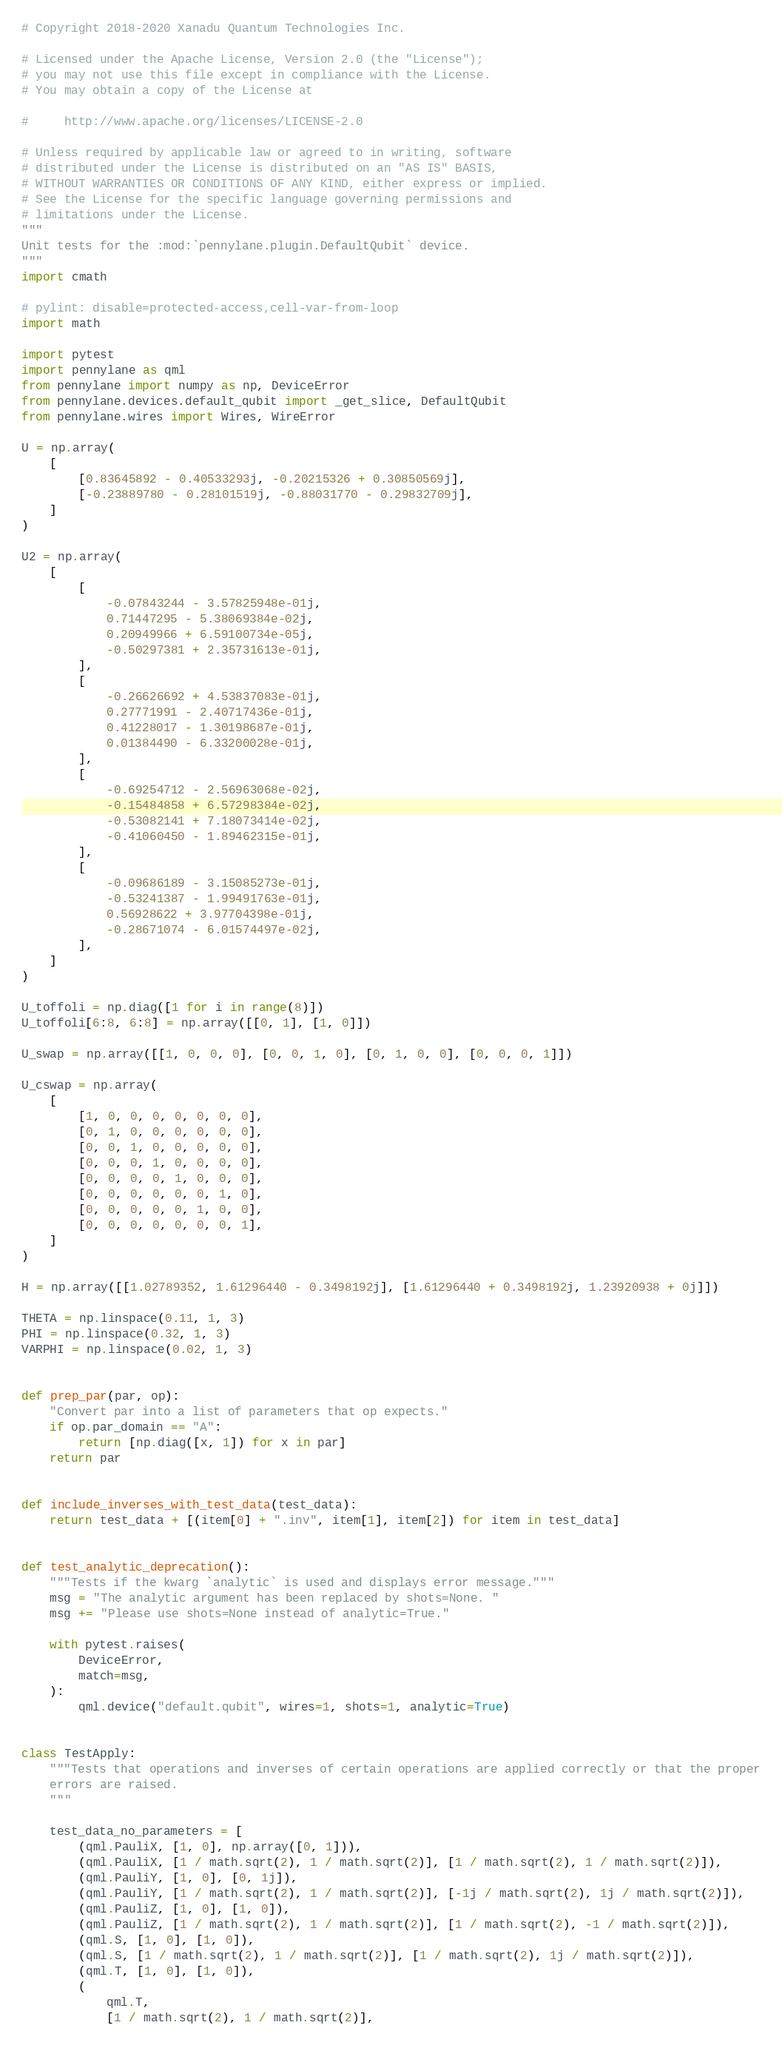<code> <loc_0><loc_0><loc_500><loc_500><_Python_># Copyright 2018-2020 Xanadu Quantum Technologies Inc.

# Licensed under the Apache License, Version 2.0 (the "License");
# you may not use this file except in compliance with the License.
# You may obtain a copy of the License at

#     http://www.apache.org/licenses/LICENSE-2.0

# Unless required by applicable law or agreed to in writing, software
# distributed under the License is distributed on an "AS IS" BASIS,
# WITHOUT WARRANTIES OR CONDITIONS OF ANY KIND, either express or implied.
# See the License for the specific language governing permissions and
# limitations under the License.
"""
Unit tests for the :mod:`pennylane.plugin.DefaultQubit` device.
"""
import cmath

# pylint: disable=protected-access,cell-var-from-loop
import math

import pytest
import pennylane as qml
from pennylane import numpy as np, DeviceError
from pennylane.devices.default_qubit import _get_slice, DefaultQubit
from pennylane.wires import Wires, WireError

U = np.array(
    [
        [0.83645892 - 0.40533293j, -0.20215326 + 0.30850569j],
        [-0.23889780 - 0.28101519j, -0.88031770 - 0.29832709j],
    ]
)

U2 = np.array(
    [
        [
            -0.07843244 - 3.57825948e-01j,
            0.71447295 - 5.38069384e-02j,
            0.20949966 + 6.59100734e-05j,
            -0.50297381 + 2.35731613e-01j,
        ],
        [
            -0.26626692 + 4.53837083e-01j,
            0.27771991 - 2.40717436e-01j,
            0.41228017 - 1.30198687e-01j,
            0.01384490 - 6.33200028e-01j,
        ],
        [
            -0.69254712 - 2.56963068e-02j,
            -0.15484858 + 6.57298384e-02j,
            -0.53082141 + 7.18073414e-02j,
            -0.41060450 - 1.89462315e-01j,
        ],
        [
            -0.09686189 - 3.15085273e-01j,
            -0.53241387 - 1.99491763e-01j,
            0.56928622 + 3.97704398e-01j,
            -0.28671074 - 6.01574497e-02j,
        ],
    ]
)

U_toffoli = np.diag([1 for i in range(8)])
U_toffoli[6:8, 6:8] = np.array([[0, 1], [1, 0]])

U_swap = np.array([[1, 0, 0, 0], [0, 0, 1, 0], [0, 1, 0, 0], [0, 0, 0, 1]])

U_cswap = np.array(
    [
        [1, 0, 0, 0, 0, 0, 0, 0],
        [0, 1, 0, 0, 0, 0, 0, 0],
        [0, 0, 1, 0, 0, 0, 0, 0],
        [0, 0, 0, 1, 0, 0, 0, 0],
        [0, 0, 0, 0, 1, 0, 0, 0],
        [0, 0, 0, 0, 0, 0, 1, 0],
        [0, 0, 0, 0, 0, 1, 0, 0],
        [0, 0, 0, 0, 0, 0, 0, 1],
    ]
)

H = np.array([[1.02789352, 1.61296440 - 0.3498192j], [1.61296440 + 0.3498192j, 1.23920938 + 0j]])

THETA = np.linspace(0.11, 1, 3)
PHI = np.linspace(0.32, 1, 3)
VARPHI = np.linspace(0.02, 1, 3)


def prep_par(par, op):
    "Convert par into a list of parameters that op expects."
    if op.par_domain == "A":
        return [np.diag([x, 1]) for x in par]
    return par


def include_inverses_with_test_data(test_data):
    return test_data + [(item[0] + ".inv", item[1], item[2]) for item in test_data]


def test_analytic_deprecation():
    """Tests if the kwarg `analytic` is used and displays error message."""
    msg = "The analytic argument has been replaced by shots=None. "
    msg += "Please use shots=None instead of analytic=True."

    with pytest.raises(
        DeviceError,
        match=msg,
    ):
        qml.device("default.qubit", wires=1, shots=1, analytic=True)


class TestApply:
    """Tests that operations and inverses of certain operations are applied correctly or that the proper
    errors are raised.
    """

    test_data_no_parameters = [
        (qml.PauliX, [1, 0], np.array([0, 1])),
        (qml.PauliX, [1 / math.sqrt(2), 1 / math.sqrt(2)], [1 / math.sqrt(2), 1 / math.sqrt(2)]),
        (qml.PauliY, [1, 0], [0, 1j]),
        (qml.PauliY, [1 / math.sqrt(2), 1 / math.sqrt(2)], [-1j / math.sqrt(2), 1j / math.sqrt(2)]),
        (qml.PauliZ, [1, 0], [1, 0]),
        (qml.PauliZ, [1 / math.sqrt(2), 1 / math.sqrt(2)], [1 / math.sqrt(2), -1 / math.sqrt(2)]),
        (qml.S, [1, 0], [1, 0]),
        (qml.S, [1 / math.sqrt(2), 1 / math.sqrt(2)], [1 / math.sqrt(2), 1j / math.sqrt(2)]),
        (qml.T, [1, 0], [1, 0]),
        (
            qml.T,
            [1 / math.sqrt(2), 1 / math.sqrt(2)],</code> 